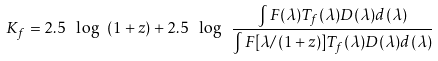<formula> <loc_0><loc_0><loc_500><loc_500>K _ { f } = 2 . 5 \ \log \ ( 1 + z ) + 2 . 5 \ \log \ \frac { \int F ( \lambda ) T _ { f } ( \lambda ) D ( \lambda ) d ( \lambda ) } { \int F [ \lambda / ( 1 + z ) ] T _ { f } ( \lambda ) D ( \lambda ) d ( \lambda ) }</formula> 